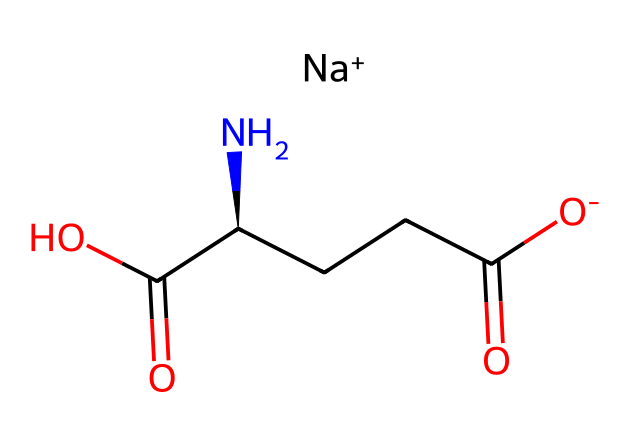What is the name of this chemical? The SMILES representation indicates the presence of the sodium ion (Na+), an amino group (NH2), and other components that are characteristic of glutamate. The full name combining these aspects is Monosodium Glutamate.
Answer: Monosodium Glutamate How many carbon atoms are in the structure? By examining the SMILES notation, we can count the number of carbon atoms (C). There are four carbon atoms present in the structure.
Answer: 4 What is the charge of the sodium ion in this chemical? The presence of the notation [Na+] indicates that the sodium ion has a positive charge, which is a defining characteristic of its role in this compound.
Answer: +1 What functional groups are present in the chemical? The structure shows there are a carboxylic acid group (-COOH) and an amine group (-NH2) in addition to the sodium ion, which are typical functional groups found in amino acids and corresponding salts.
Answer: Carboxylic acid, amine How does the presence of sodium affect the solubility of this compound? Sodium ions typically increase the solubility of compounds in water due to their ability to interact with water molecules, thus enhancing the overall solubility of Monosodium Glutamate in aqueous solutions.
Answer: Increases solubility What is the role of MSG in food? Monosodium Glutamate is primarily used as a flavor enhancer to improve the taste of foods by providing umami flavor, which is often described as savory.
Answer: Flavor enhancer Why is MSG considered safe for consumption? Numerous studies and regulatory bodies have evaluated monosodium glutamate and found that it is safe for human consumption at normal dietary levels, with no significant adverse effects.
Answer: Safe for consumption 